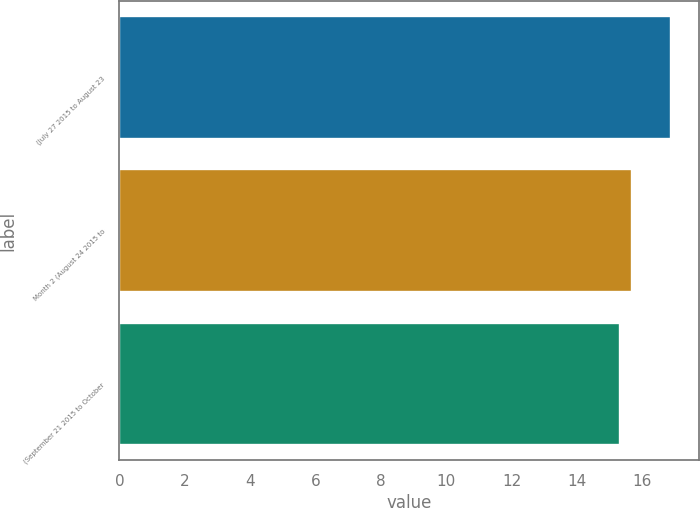Convert chart to OTSL. <chart><loc_0><loc_0><loc_500><loc_500><bar_chart><fcel>(July 27 2015 to August 23<fcel>Month 2 (August 24 2015 to<fcel>(September 21 2015 to October<nl><fcel>16.89<fcel>15.69<fcel>15.32<nl></chart> 